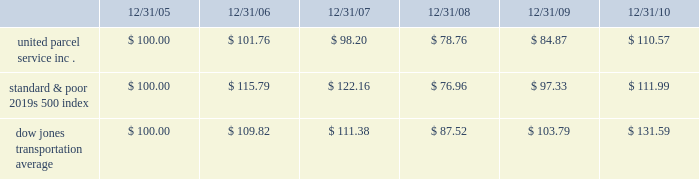Shareowner return performance graph the following performance graph and related information shall not be deemed 201csoliciting material 201d or to be 201cfiled 201d with the securities and exchange commission , nor shall such information be incorporated by reference into any future filing under the securities act of 1933 or securities exchange act of 1934 , each as amended , except to the extent that the company specifically incorporates such information by reference into such filing .
The following graph shows a five year comparison of cumulative total shareowners 2019 returns for our class b common stock , the standard & poor 2019s 500 index , and the dow jones transportation average .
The comparison of the total cumulative return on investment , which is the change in the quarterly stock price plus reinvested dividends for each of the quarterly periods , assumes that $ 100 was invested on december 31 , 2005 in the standard & poor 2019s 500 index , the dow jones transportation average , and our class b common stock .
Comparison of five year cumulative total return $ 40.00 $ 60.00 $ 80.00 $ 100.00 $ 120.00 $ 140.00 $ 160.00 201020092008200720062005 s&p 500 ups dj transport .

What is the difference in total cumulative return on investment between united parcel service inc . and the standard & poor 2019s 500 index for the five year period ending 12/31/10? 
Computations: (((110.57 - 100) / 100) - ((111.99 - 100) / 100))
Answer: -0.0142. 